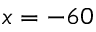<formula> <loc_0><loc_0><loc_500><loc_500>x = - 6 0</formula> 